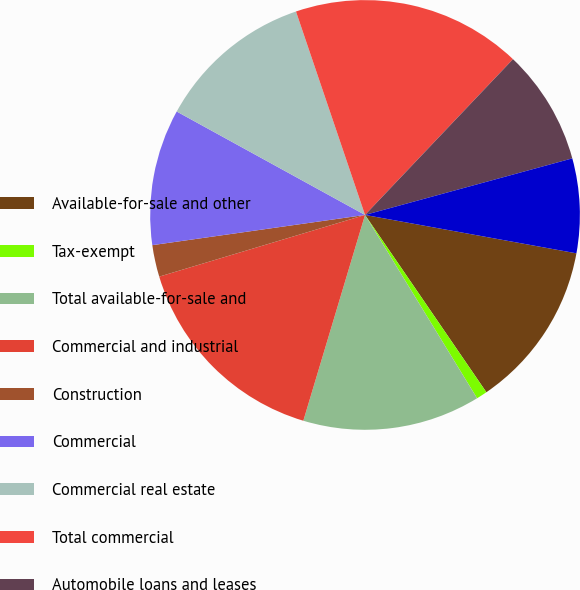Convert chart to OTSL. <chart><loc_0><loc_0><loc_500><loc_500><pie_chart><fcel>Available-for-sale and other<fcel>Tax-exempt<fcel>Total available-for-sale and<fcel>Commercial and industrial<fcel>Construction<fcel>Commercial<fcel>Commercial real estate<fcel>Total commercial<fcel>Automobile loans and leases<fcel>Residential mortgage<nl><fcel>12.59%<fcel>0.82%<fcel>13.37%<fcel>15.73%<fcel>2.39%<fcel>10.24%<fcel>11.8%<fcel>17.3%<fcel>8.67%<fcel>7.1%<nl></chart> 